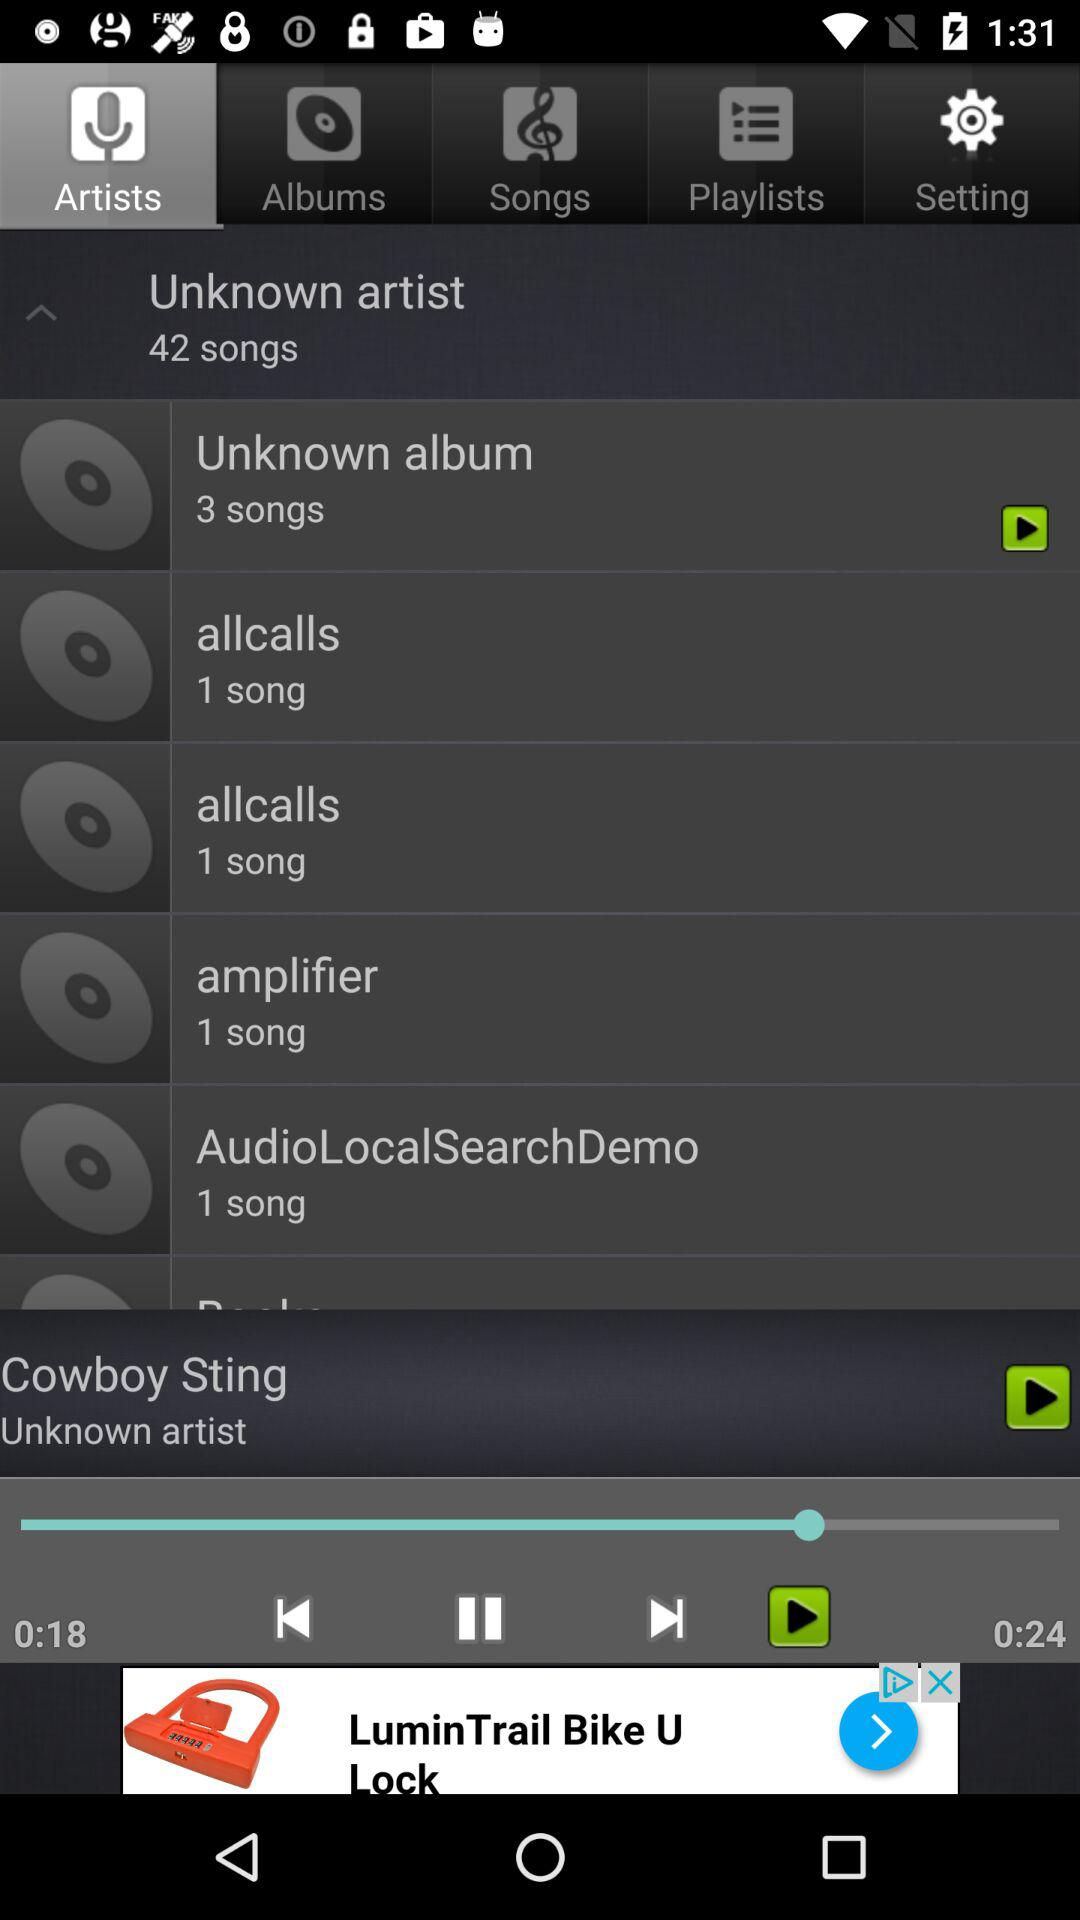Which song is playing? The song that is playing is Cowboy Sting. 